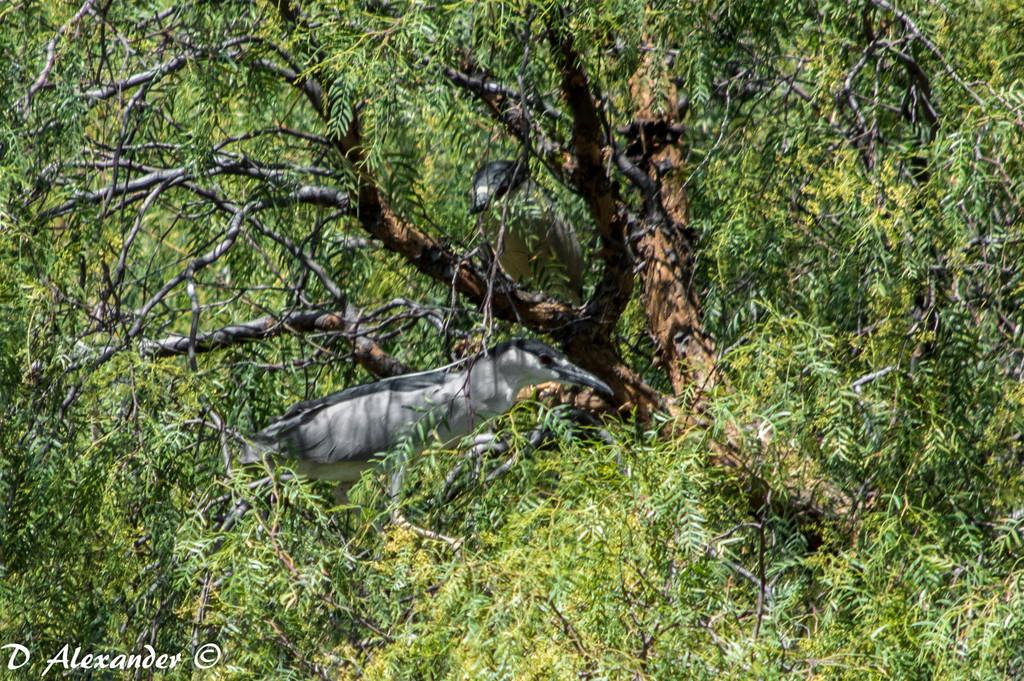How many birds are present in the image? There are two birds in the image. Where are the birds located? The birds are on trees. What is the aftermath of the window breaking in the image? There is no window breaking in the image, and therefore no aftermath to describe. 